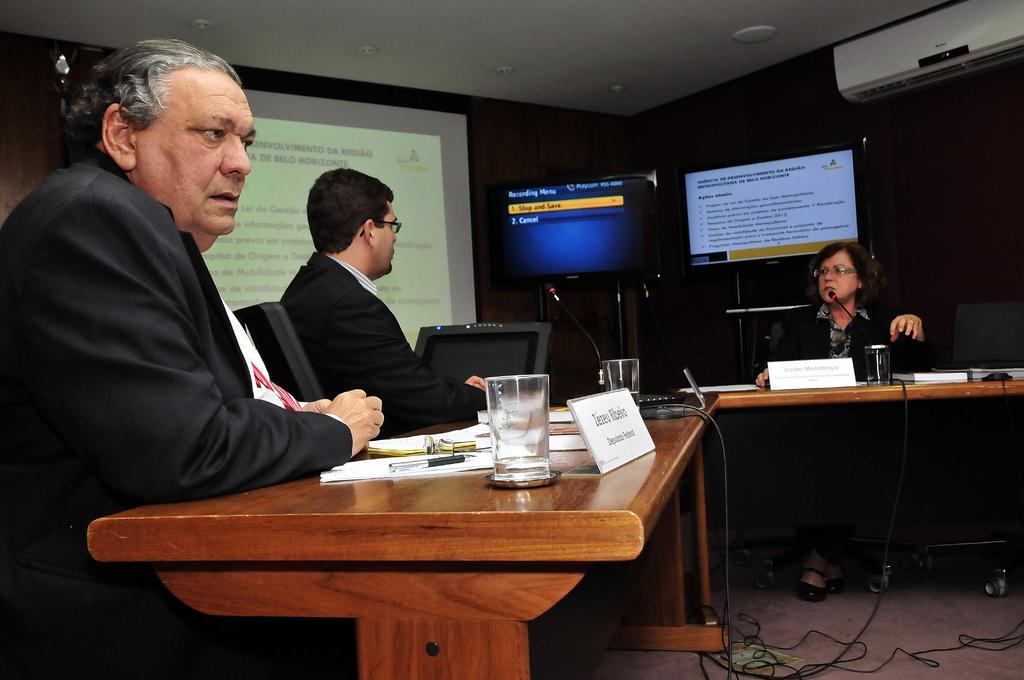Describe this image in one or two sentences. In this image, There are three persons sitting in front of this table. This table contains glasses and some papers. These two persons are wearing spectacles on their head. There are two monitors behind this persons. There is an AC at the top. There is screen behind this table. 